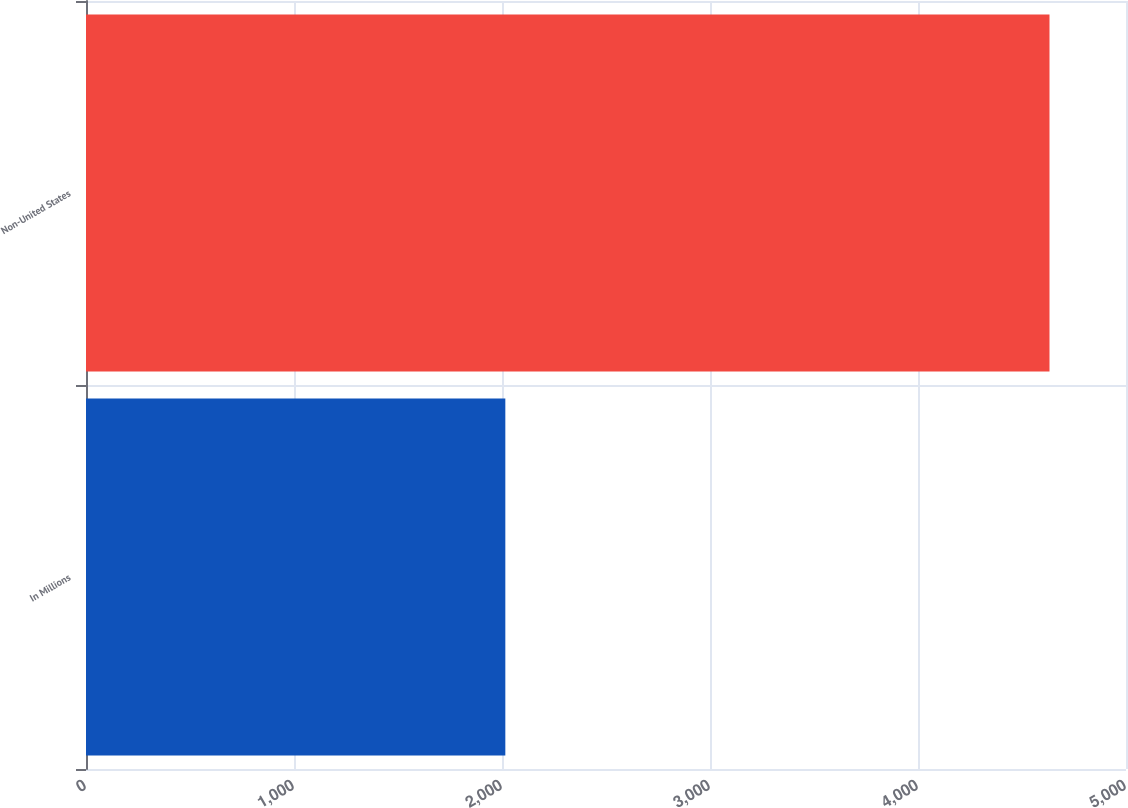Convert chart. <chart><loc_0><loc_0><loc_500><loc_500><bar_chart><fcel>In Millions<fcel>Non-United States<nl><fcel>2016<fcel>4632.2<nl></chart> 